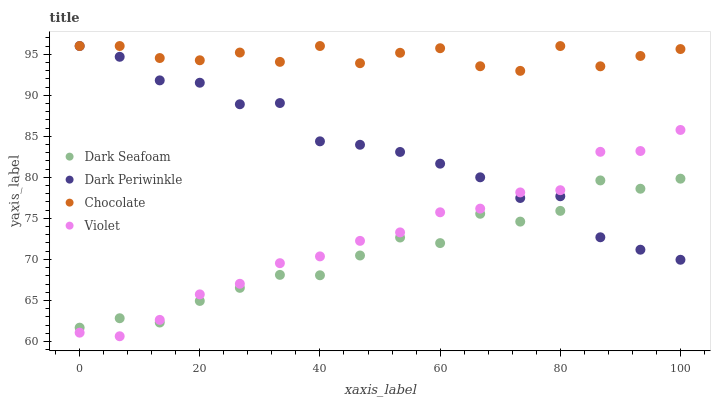Does Dark Seafoam have the minimum area under the curve?
Answer yes or no. Yes. Does Chocolate have the maximum area under the curve?
Answer yes or no. Yes. Does Violet have the minimum area under the curve?
Answer yes or no. No. Does Violet have the maximum area under the curve?
Answer yes or no. No. Is Violet the smoothest?
Answer yes or no. Yes. Is Chocolate the roughest?
Answer yes or no. Yes. Is Dark Periwinkle the smoothest?
Answer yes or no. No. Is Dark Periwinkle the roughest?
Answer yes or no. No. Does Violet have the lowest value?
Answer yes or no. Yes. Does Dark Periwinkle have the lowest value?
Answer yes or no. No. Does Chocolate have the highest value?
Answer yes or no. Yes. Does Violet have the highest value?
Answer yes or no. No. Is Dark Seafoam less than Chocolate?
Answer yes or no. Yes. Is Chocolate greater than Violet?
Answer yes or no. Yes. Does Dark Periwinkle intersect Dark Seafoam?
Answer yes or no. Yes. Is Dark Periwinkle less than Dark Seafoam?
Answer yes or no. No. Is Dark Periwinkle greater than Dark Seafoam?
Answer yes or no. No. Does Dark Seafoam intersect Chocolate?
Answer yes or no. No. 